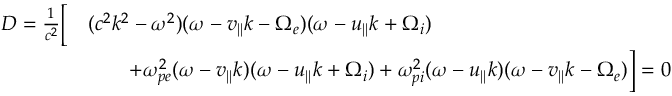Convert formula to latex. <formula><loc_0><loc_0><loc_500><loc_500>\begin{array} { r l } { D = \frac { 1 } { c ^ { 2 } } \left [ } & { ( c ^ { 2 } k ^ { 2 } - \omega ^ { 2 } ) ( \omega - v _ { | | } k - \Omega _ { e } ) ( \omega - u _ { | | } k + \Omega _ { i } ) } \\ & { \quad + \omega _ { p e } ^ { 2 } ( \omega - v _ { | | } k ) ( \omega - u _ { | | } k + \Omega _ { i } ) + \omega _ { p i } ^ { 2 } ( \omega - u _ { | | } k ) ( \omega - v _ { | | } k - \Omega _ { e } ) \right ] = 0 } \end{array}</formula> 